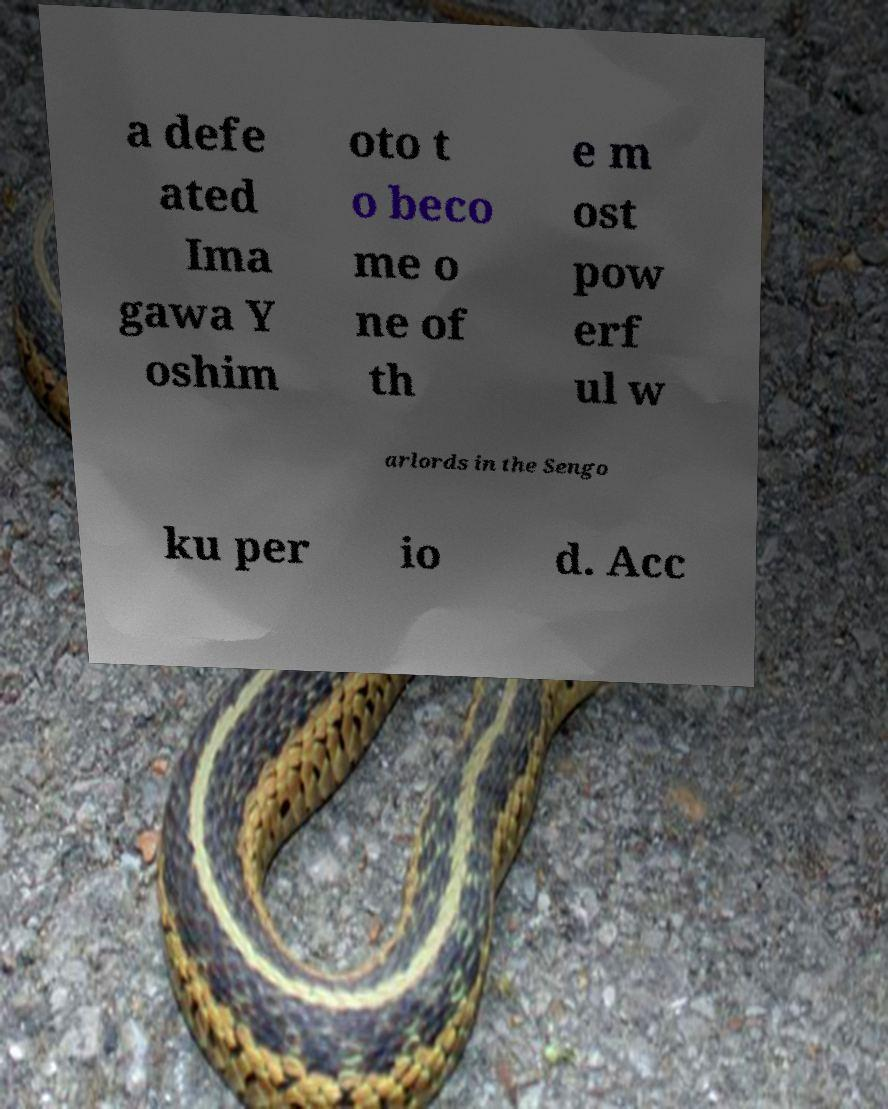Please identify and transcribe the text found in this image. a defe ated Ima gawa Y oshim oto t o beco me o ne of th e m ost pow erf ul w arlords in the Sengo ku per io d. Acc 